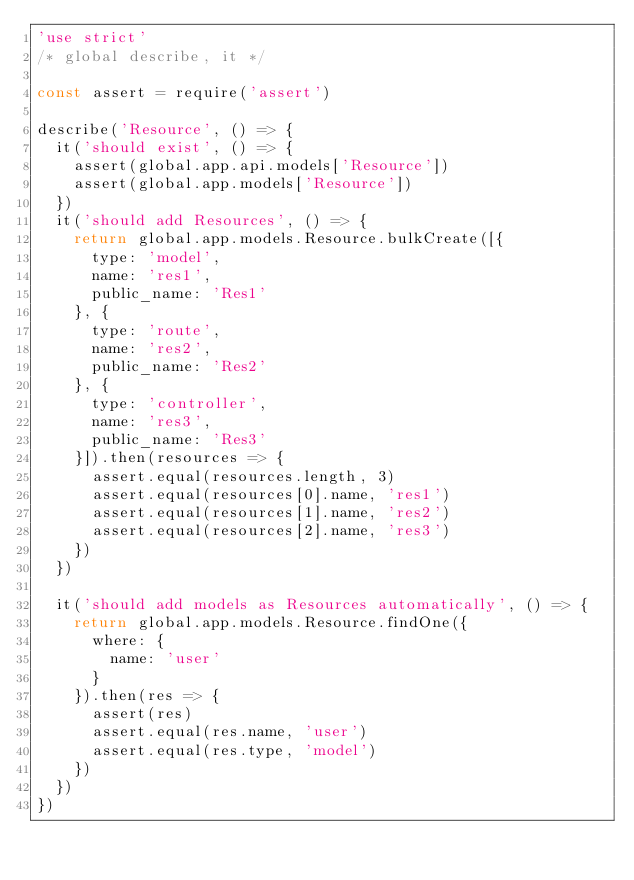<code> <loc_0><loc_0><loc_500><loc_500><_JavaScript_>'use strict'
/* global describe, it */

const assert = require('assert')

describe('Resource', () => {
  it('should exist', () => {
    assert(global.app.api.models['Resource'])
    assert(global.app.models['Resource'])
  })
  it('should add Resources', () => {
    return global.app.models.Resource.bulkCreate([{
      type: 'model',
      name: 'res1',
      public_name: 'Res1'
    }, {
      type: 'route',
      name: 'res2',
      public_name: 'Res2'
    }, {
      type: 'controller',
      name: 'res3',
      public_name: 'Res3'
    }]).then(resources => {
      assert.equal(resources.length, 3)
      assert.equal(resources[0].name, 'res1')
      assert.equal(resources[1].name, 'res2')
      assert.equal(resources[2].name, 'res3')
    })
  })

  it('should add models as Resources automatically', () => {
    return global.app.models.Resource.findOne({
      where: {
        name: 'user'
      }
    }).then(res => {
      assert(res)
      assert.equal(res.name, 'user')
      assert.equal(res.type, 'model')
    })
  })
})
</code> 